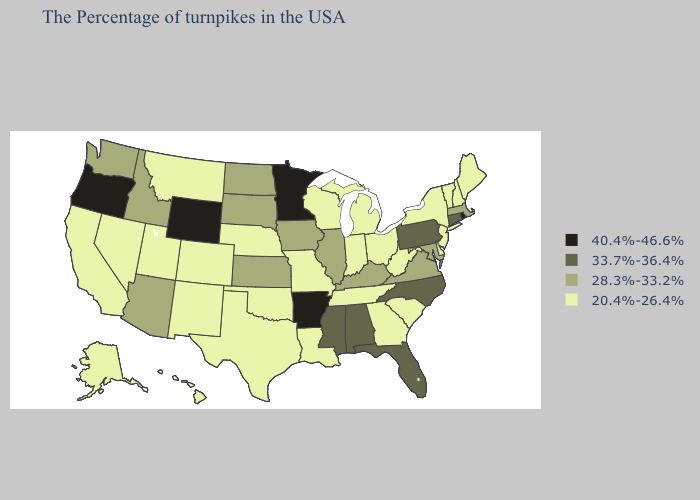Name the states that have a value in the range 20.4%-26.4%?
Quick response, please. Maine, New Hampshire, Vermont, New York, New Jersey, Delaware, South Carolina, West Virginia, Ohio, Georgia, Michigan, Indiana, Tennessee, Wisconsin, Louisiana, Missouri, Nebraska, Oklahoma, Texas, Colorado, New Mexico, Utah, Montana, Nevada, California, Alaska, Hawaii. Does New Hampshire have the highest value in the Northeast?
Keep it brief. No. Among the states that border Louisiana , does Arkansas have the highest value?
Concise answer only. Yes. Does Rhode Island have the same value as Wyoming?
Quick response, please. Yes. Which states have the lowest value in the South?
Write a very short answer. Delaware, South Carolina, West Virginia, Georgia, Tennessee, Louisiana, Oklahoma, Texas. What is the lowest value in the West?
Give a very brief answer. 20.4%-26.4%. What is the lowest value in states that border Maryland?
Give a very brief answer. 20.4%-26.4%. Does the first symbol in the legend represent the smallest category?
Write a very short answer. No. Name the states that have a value in the range 40.4%-46.6%?
Short answer required. Rhode Island, Arkansas, Minnesota, Wyoming, Oregon. What is the highest value in the Northeast ?
Write a very short answer. 40.4%-46.6%. Name the states that have a value in the range 20.4%-26.4%?
Answer briefly. Maine, New Hampshire, Vermont, New York, New Jersey, Delaware, South Carolina, West Virginia, Ohio, Georgia, Michigan, Indiana, Tennessee, Wisconsin, Louisiana, Missouri, Nebraska, Oklahoma, Texas, Colorado, New Mexico, Utah, Montana, Nevada, California, Alaska, Hawaii. Does Kentucky have the same value as South Dakota?
Give a very brief answer. Yes. What is the highest value in states that border New Hampshire?
Concise answer only. 28.3%-33.2%. What is the value of Michigan?
Short answer required. 20.4%-26.4%. Which states have the highest value in the USA?
Quick response, please. Rhode Island, Arkansas, Minnesota, Wyoming, Oregon. 